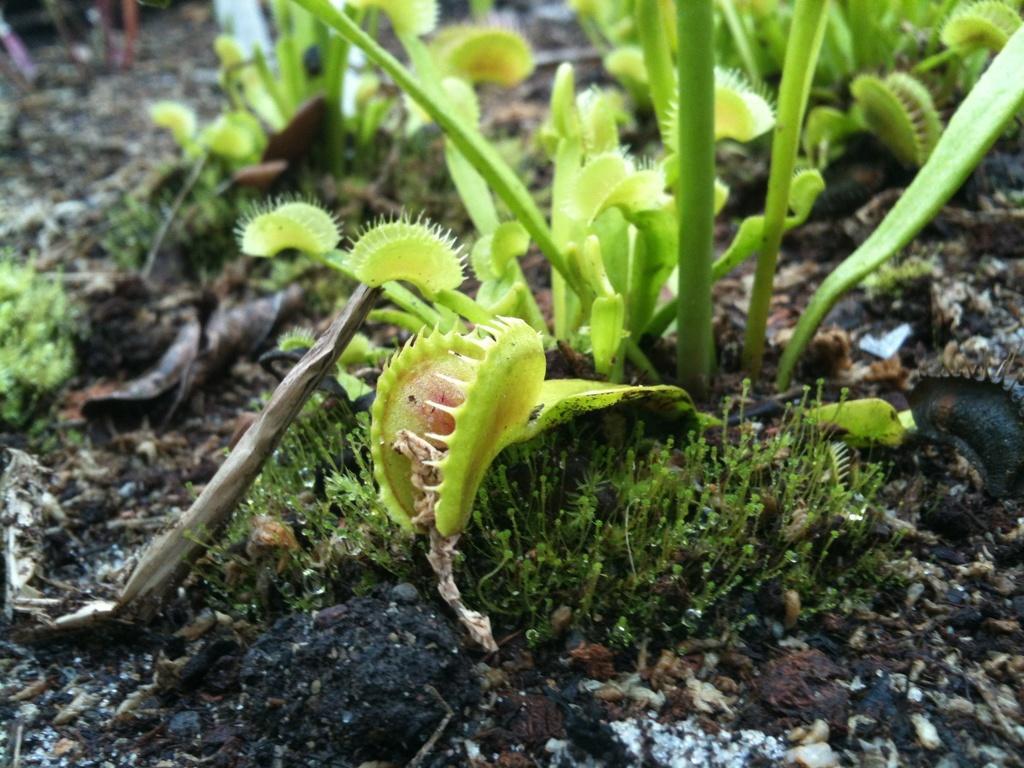Could you give a brief overview of what you see in this image? In this picture we can see few plants. 